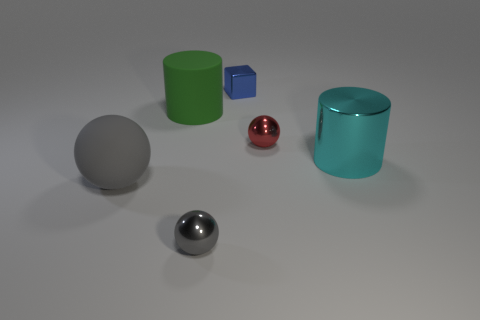How many gray balls must be subtracted to get 1 gray balls? 1 Subtract all cyan blocks. How many gray spheres are left? 2 Add 2 yellow metallic cylinders. How many objects exist? 8 Subtract all small shiny balls. How many balls are left? 1 Subtract 1 spheres. How many spheres are left? 2 Subtract all blocks. How many objects are left? 5 Subtract all brown spheres. Subtract all purple cylinders. How many spheres are left? 3 Add 2 large green cylinders. How many large green cylinders are left? 3 Add 1 tiny metal blocks. How many tiny metal blocks exist? 2 Subtract 0 red cylinders. How many objects are left? 6 